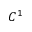Convert formula to latex. <formula><loc_0><loc_0><loc_500><loc_500>C ^ { 1 }</formula> 